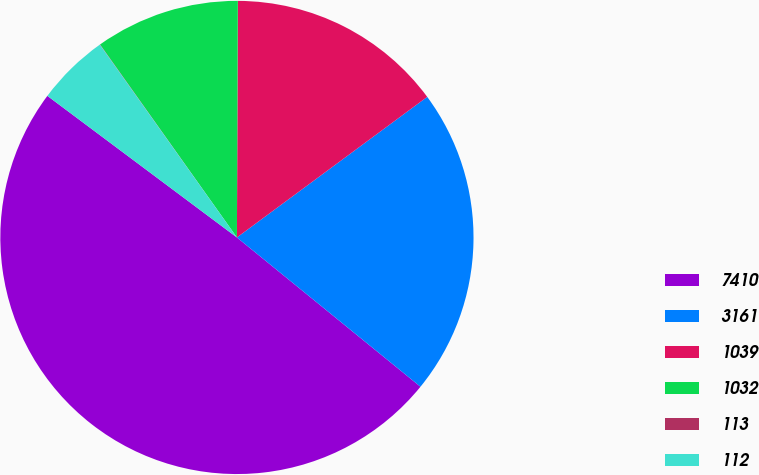Convert chart. <chart><loc_0><loc_0><loc_500><loc_500><pie_chart><fcel>7410<fcel>3161<fcel>1039<fcel>1032<fcel>113<fcel>112<nl><fcel>49.34%<fcel>20.99%<fcel>14.81%<fcel>9.88%<fcel>0.02%<fcel>4.95%<nl></chart> 